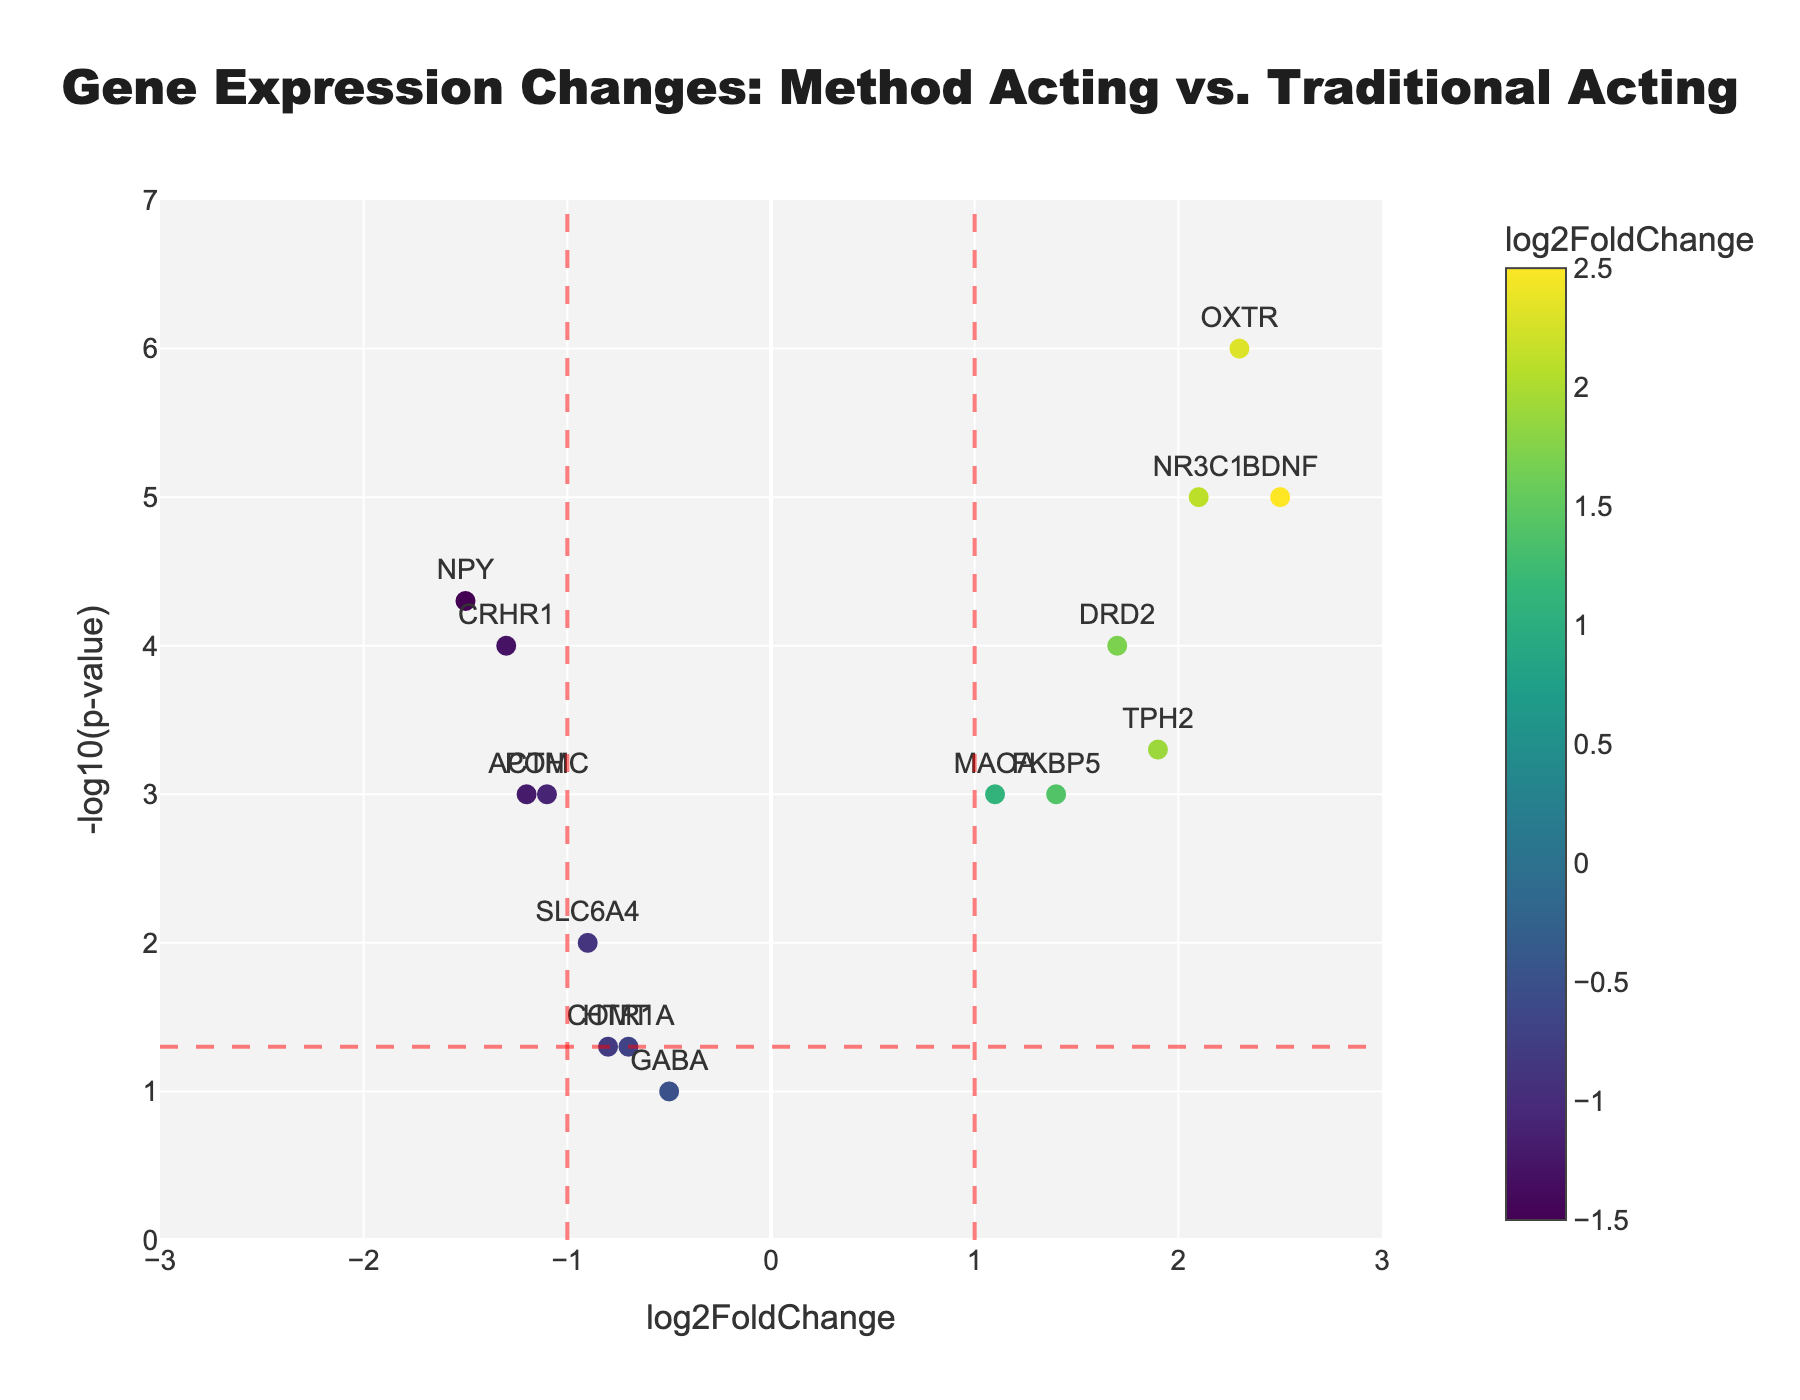what is the title of the figure? The title of the figure is displayed at the top of the plot.
Answer: Gene Expression Changes: Method Acting vs. Traditional Acting How many vertical red dashed lines are shown on the plot? The plot includes vertical lines at x = -1 and x = 1, both represented as dashed lines in red.
Answer: 2 Which gene has the highest -log10(p-value)? The gene with the highest -log10(p-value) will be located at the topmost position on the y-axis of the plot.
Answer: OXTR What does the horizontal dashed red line represent? The horizontal dashed red line corresponds to the -log10(p-value) when the p-value is 0.05. This is a threshold commonly used for significance in statistics. The formula is -log10(0.05) ≈ 1.3010.
Answer: -log10(0.05) Which gene has the highest log2FoldChange? The gene with the highest log2FoldChange can be found by identifying the point farthest to the right on the x-axis.
Answer: BDNF How many genes have a log2FoldChange greater than 1? To determine this, identify all genes plotted to the right of the vertical line at x = 1. These genes are BDNF, DRD2, MAOA, OXTR, FKBP5, TPH2, NR3C1.
Answer: 7 Are there any genes located below the horizontal dashed red line with a log2FoldChange of less than -1? Check for any gene points located below the horizontal dashed red line (indicating a p-value less significant than 0.05) and to the left of the vertical line at x = -1. GABA and HTR1A are below the red dashed horizontal line, while others are not.
Answer: No Which gene has the lowest -log10(p-value) among those with a log2FoldChange greater than 1? Among the genes with a log2FoldChange greater than 1, find the one with the lowest y-axis value. FKBP5 has the lowest -log10(p-value) in this subset.
Answer: FKBP5 Compare the log2FoldChange values of CRHR1 and FKBP5. Which one is higher? Look at the specific locations of CRHR1 and FKBP5 on the x-axis, and note the one situated further to the right. FKBP5 has a higher log2FoldChange value compared to CRHR1.
Answer: FKBP5 